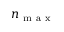Convert formula to latex. <formula><loc_0><loc_0><loc_500><loc_500>n _ { m a x }</formula> 